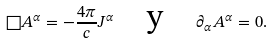Convert formula to latex. <formula><loc_0><loc_0><loc_500><loc_500>\square A ^ { \alpha } = - \frac { 4 \pi } { c } J ^ { \alpha } \quad \text {y} \quad \partial _ { \alpha } A ^ { \alpha } = 0 .</formula> 